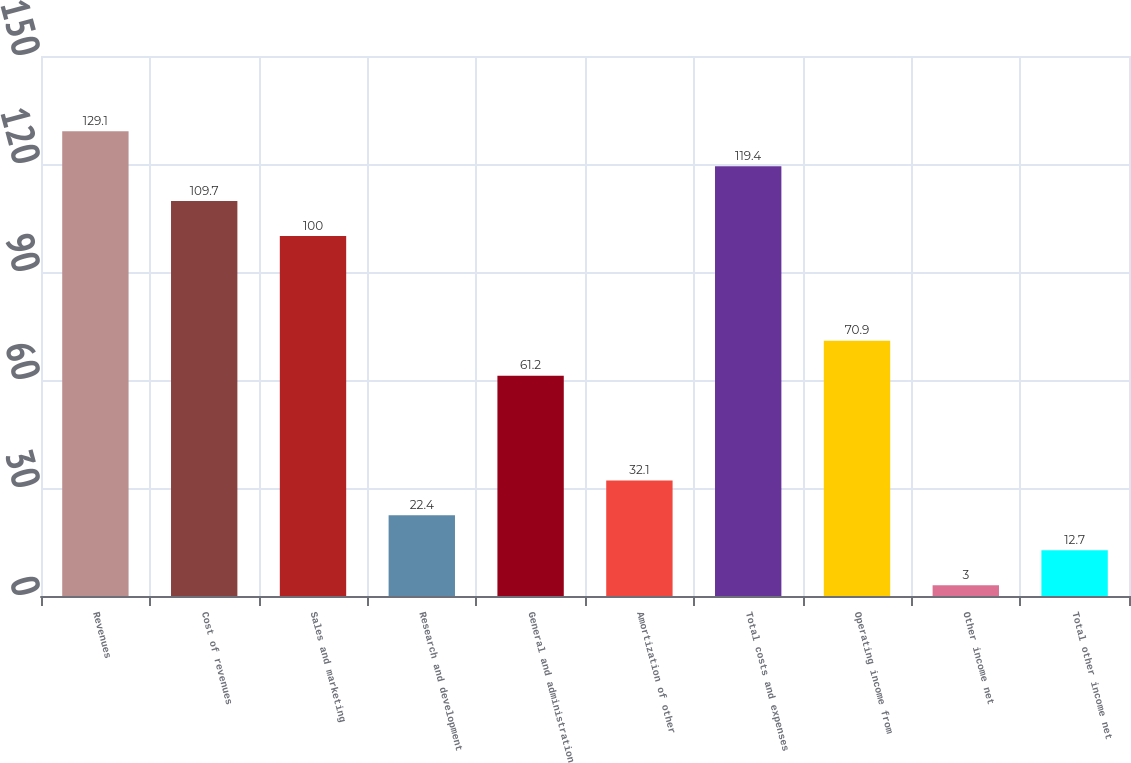Convert chart. <chart><loc_0><loc_0><loc_500><loc_500><bar_chart><fcel>Revenues<fcel>Cost of revenues<fcel>Sales and marketing<fcel>Research and development<fcel>General and administration<fcel>Amortization of other<fcel>Total costs and expenses<fcel>Operating income from<fcel>Other income net<fcel>Total other income net<nl><fcel>129.1<fcel>109.7<fcel>100<fcel>22.4<fcel>61.2<fcel>32.1<fcel>119.4<fcel>70.9<fcel>3<fcel>12.7<nl></chart> 